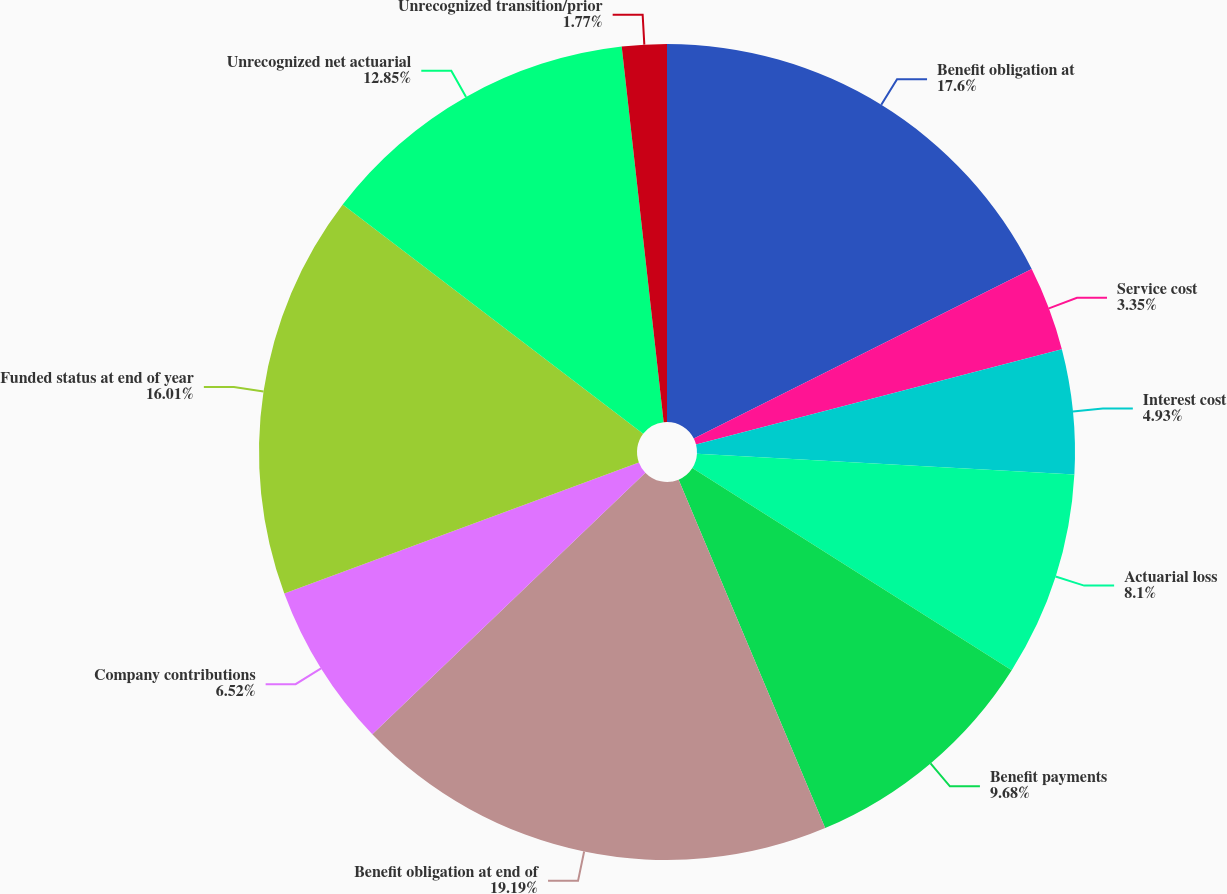Convert chart. <chart><loc_0><loc_0><loc_500><loc_500><pie_chart><fcel>Benefit obligation at<fcel>Service cost<fcel>Interest cost<fcel>Actuarial loss<fcel>Benefit payments<fcel>Benefit obligation at end of<fcel>Company contributions<fcel>Funded status at end of year<fcel>Unrecognized net actuarial<fcel>Unrecognized transition/prior<nl><fcel>17.6%<fcel>3.35%<fcel>4.93%<fcel>8.1%<fcel>9.68%<fcel>19.18%<fcel>6.52%<fcel>16.01%<fcel>12.85%<fcel>1.77%<nl></chart> 